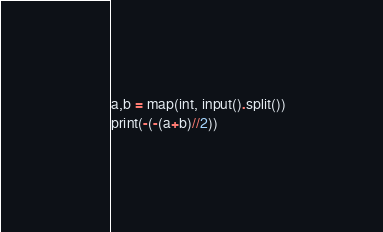<code> <loc_0><loc_0><loc_500><loc_500><_Python_>a,b = map(int, input().split())
print(-(-(a+b)//2))</code> 